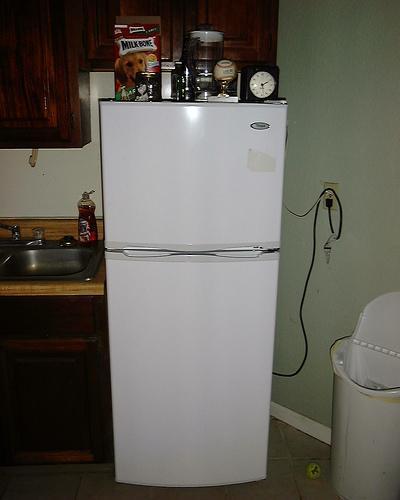How many sinks are there?
Give a very brief answer. 1. 